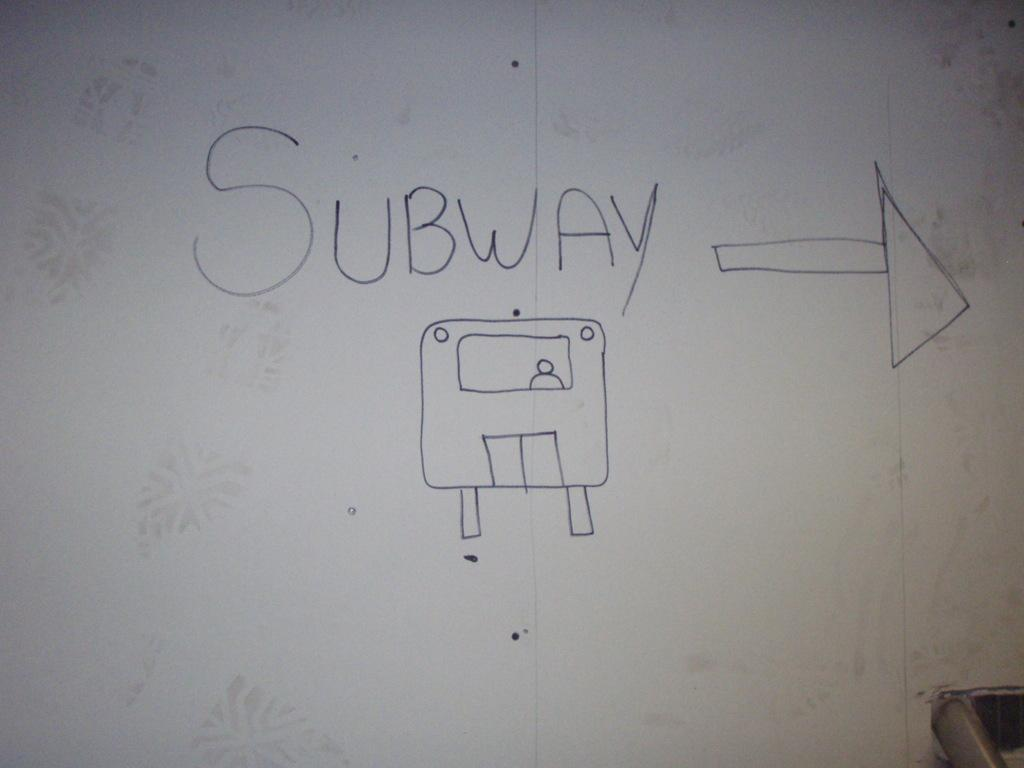<image>
Offer a succinct explanation of the picture presented. Someone has indicated that the subway is to the right, by drawing on the wall. 